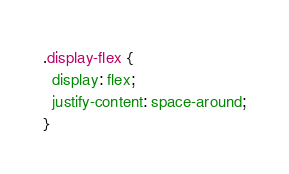<code> <loc_0><loc_0><loc_500><loc_500><_CSS_>.display-flex {
  display: flex;
  justify-content: space-around;
}
</code> 